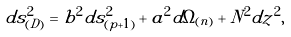Convert formula to latex. <formula><loc_0><loc_0><loc_500><loc_500>d s _ { ( D ) } ^ { 2 } = b ^ { 2 } d s ^ { 2 } _ { ( p + 1 ) } + a ^ { 2 } d \Omega _ { ( n ) } + N ^ { 2 } d z ^ { 2 } ,</formula> 